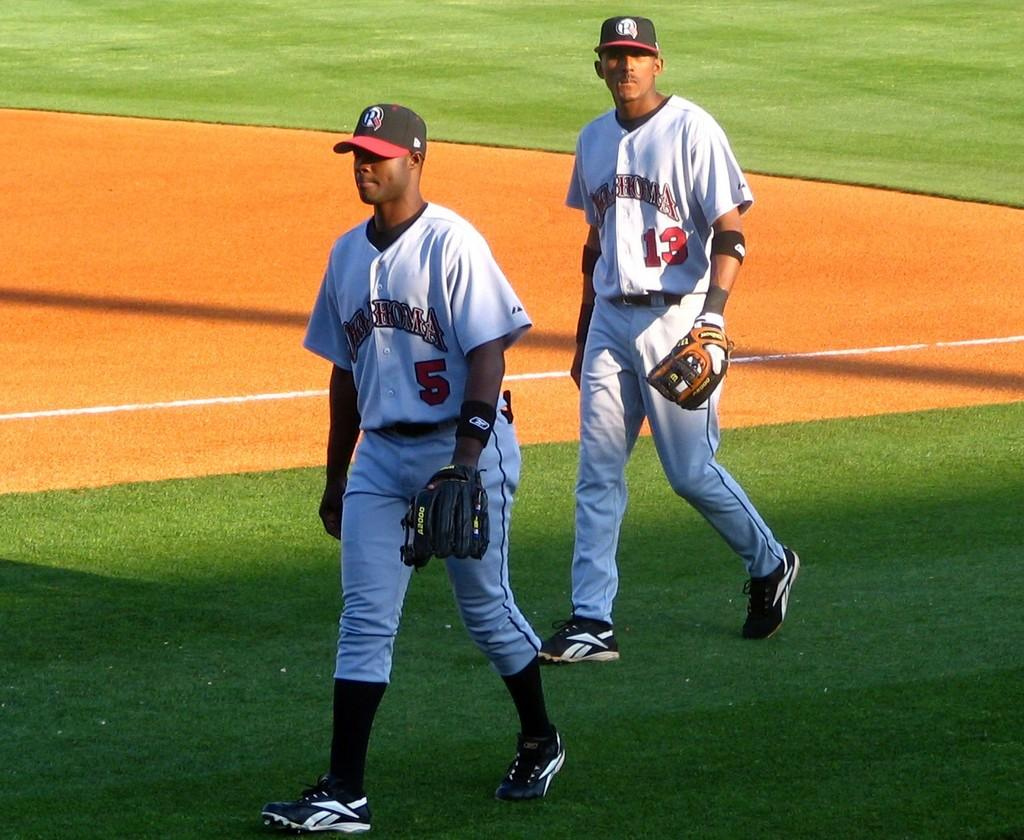<image>
Create a compact narrative representing the image presented. Two baseball players walking and one has the number 5 on his jersey. 